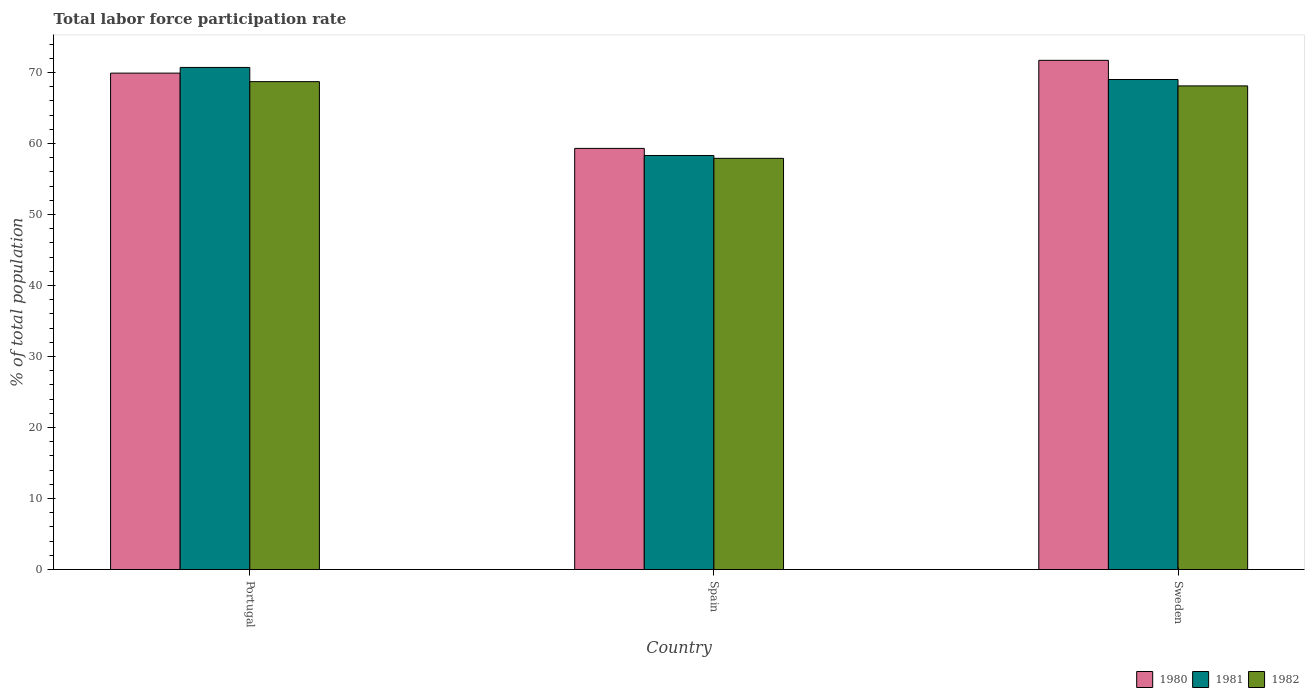How many different coloured bars are there?
Offer a very short reply. 3. How many groups of bars are there?
Provide a succinct answer. 3. Are the number of bars per tick equal to the number of legend labels?
Offer a terse response. Yes. Are the number of bars on each tick of the X-axis equal?
Offer a very short reply. Yes. How many bars are there on the 2nd tick from the left?
Your response must be concise. 3. What is the label of the 1st group of bars from the left?
Your answer should be compact. Portugal. In how many cases, is the number of bars for a given country not equal to the number of legend labels?
Your response must be concise. 0. What is the total labor force participation rate in 1981 in Portugal?
Your answer should be very brief. 70.7. Across all countries, what is the maximum total labor force participation rate in 1981?
Provide a succinct answer. 70.7. Across all countries, what is the minimum total labor force participation rate in 1981?
Offer a very short reply. 58.3. In which country was the total labor force participation rate in 1980 maximum?
Ensure brevity in your answer.  Sweden. What is the total total labor force participation rate in 1980 in the graph?
Provide a short and direct response. 200.9. What is the difference between the total labor force participation rate in 1982 in Portugal and that in Sweden?
Give a very brief answer. 0.6. What is the difference between the total labor force participation rate in 1981 in Sweden and the total labor force participation rate in 1980 in Portugal?
Keep it short and to the point. -0.9. What is the average total labor force participation rate in 1981 per country?
Your answer should be very brief. 66. What is the difference between the total labor force participation rate of/in 1982 and total labor force participation rate of/in 1980 in Portugal?
Offer a very short reply. -1.2. In how many countries, is the total labor force participation rate in 1980 greater than 32 %?
Your answer should be compact. 3. What is the ratio of the total labor force participation rate in 1981 in Portugal to that in Spain?
Provide a short and direct response. 1.21. Is the total labor force participation rate in 1980 in Portugal less than that in Sweden?
Your answer should be very brief. Yes. Is the difference between the total labor force participation rate in 1982 in Portugal and Sweden greater than the difference between the total labor force participation rate in 1980 in Portugal and Sweden?
Provide a succinct answer. Yes. What is the difference between the highest and the second highest total labor force participation rate in 1982?
Provide a succinct answer. -10.8. What is the difference between the highest and the lowest total labor force participation rate in 1982?
Ensure brevity in your answer.  10.8. Is the sum of the total labor force participation rate in 1981 in Spain and Sweden greater than the maximum total labor force participation rate in 1980 across all countries?
Keep it short and to the point. Yes. What does the 2nd bar from the left in Sweden represents?
Keep it short and to the point. 1981. What does the 3rd bar from the right in Portugal represents?
Provide a short and direct response. 1980. Is it the case that in every country, the sum of the total labor force participation rate in 1980 and total labor force participation rate in 1981 is greater than the total labor force participation rate in 1982?
Give a very brief answer. Yes. How many bars are there?
Your answer should be very brief. 9. How many countries are there in the graph?
Your response must be concise. 3. Does the graph contain grids?
Give a very brief answer. No. Where does the legend appear in the graph?
Give a very brief answer. Bottom right. How are the legend labels stacked?
Provide a short and direct response. Horizontal. What is the title of the graph?
Provide a succinct answer. Total labor force participation rate. What is the label or title of the Y-axis?
Your response must be concise. % of total population. What is the % of total population of 1980 in Portugal?
Make the answer very short. 69.9. What is the % of total population of 1981 in Portugal?
Give a very brief answer. 70.7. What is the % of total population of 1982 in Portugal?
Make the answer very short. 68.7. What is the % of total population in 1980 in Spain?
Your response must be concise. 59.3. What is the % of total population of 1981 in Spain?
Offer a very short reply. 58.3. What is the % of total population in 1982 in Spain?
Make the answer very short. 57.9. What is the % of total population of 1980 in Sweden?
Your answer should be very brief. 71.7. What is the % of total population in 1982 in Sweden?
Give a very brief answer. 68.1. Across all countries, what is the maximum % of total population in 1980?
Your answer should be very brief. 71.7. Across all countries, what is the maximum % of total population in 1981?
Give a very brief answer. 70.7. Across all countries, what is the maximum % of total population of 1982?
Your answer should be very brief. 68.7. Across all countries, what is the minimum % of total population in 1980?
Offer a terse response. 59.3. Across all countries, what is the minimum % of total population in 1981?
Keep it short and to the point. 58.3. Across all countries, what is the minimum % of total population in 1982?
Your answer should be very brief. 57.9. What is the total % of total population of 1980 in the graph?
Provide a succinct answer. 200.9. What is the total % of total population of 1981 in the graph?
Your answer should be very brief. 198. What is the total % of total population in 1982 in the graph?
Provide a succinct answer. 194.7. What is the difference between the % of total population of 1980 in Portugal and that in Spain?
Keep it short and to the point. 10.6. What is the difference between the % of total population in 1981 in Portugal and that in Spain?
Give a very brief answer. 12.4. What is the difference between the % of total population in 1982 in Portugal and that in Spain?
Your answer should be compact. 10.8. What is the difference between the % of total population in 1981 in Portugal and that in Sweden?
Provide a succinct answer. 1.7. What is the difference between the % of total population of 1982 in Portugal and that in Sweden?
Your answer should be very brief. 0.6. What is the difference between the % of total population in 1981 in Spain and that in Sweden?
Your answer should be very brief. -10.7. What is the difference between the % of total population of 1982 in Spain and that in Sweden?
Ensure brevity in your answer.  -10.2. What is the difference between the % of total population in 1980 in Portugal and the % of total population in 1981 in Spain?
Provide a succinct answer. 11.6. What is the difference between the % of total population of 1981 in Portugal and the % of total population of 1982 in Spain?
Provide a succinct answer. 12.8. What is the difference between the % of total population of 1980 in Portugal and the % of total population of 1981 in Sweden?
Give a very brief answer. 0.9. What is the difference between the % of total population in 1981 in Portugal and the % of total population in 1982 in Sweden?
Ensure brevity in your answer.  2.6. What is the average % of total population of 1980 per country?
Your answer should be very brief. 66.97. What is the average % of total population in 1982 per country?
Keep it short and to the point. 64.9. What is the difference between the % of total population of 1980 and % of total population of 1982 in Spain?
Offer a very short reply. 1.4. What is the difference between the % of total population in 1980 and % of total population in 1982 in Sweden?
Provide a short and direct response. 3.6. What is the difference between the % of total population in 1981 and % of total population in 1982 in Sweden?
Your answer should be compact. 0.9. What is the ratio of the % of total population of 1980 in Portugal to that in Spain?
Give a very brief answer. 1.18. What is the ratio of the % of total population of 1981 in Portugal to that in Spain?
Provide a succinct answer. 1.21. What is the ratio of the % of total population of 1982 in Portugal to that in Spain?
Your answer should be very brief. 1.19. What is the ratio of the % of total population in 1980 in Portugal to that in Sweden?
Ensure brevity in your answer.  0.97. What is the ratio of the % of total population in 1981 in Portugal to that in Sweden?
Ensure brevity in your answer.  1.02. What is the ratio of the % of total population of 1982 in Portugal to that in Sweden?
Offer a very short reply. 1.01. What is the ratio of the % of total population of 1980 in Spain to that in Sweden?
Keep it short and to the point. 0.83. What is the ratio of the % of total population in 1981 in Spain to that in Sweden?
Make the answer very short. 0.84. What is the ratio of the % of total population in 1982 in Spain to that in Sweden?
Ensure brevity in your answer.  0.85. What is the difference between the highest and the second highest % of total population in 1980?
Your response must be concise. 1.8. What is the difference between the highest and the second highest % of total population in 1982?
Give a very brief answer. 0.6. What is the difference between the highest and the lowest % of total population in 1980?
Ensure brevity in your answer.  12.4. 